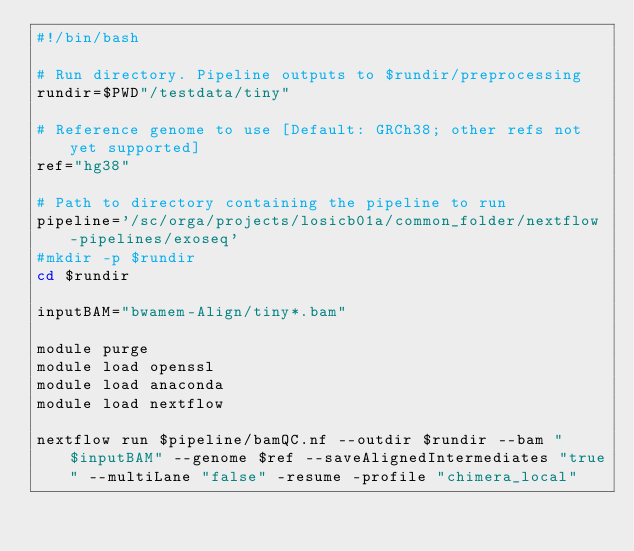<code> <loc_0><loc_0><loc_500><loc_500><_Bash_>#!/bin/bash

# Run directory. Pipeline outputs to $rundir/preprocessing
rundir=$PWD"/testdata/tiny"

# Reference genome to use [Default: GRCh38; other refs not yet supported]
ref="hg38"

# Path to directory containing the pipeline to run
pipeline='/sc/orga/projects/losicb01a/common_folder/nextflow-pipelines/exoseq'
#mkdir -p $rundir
cd $rundir

inputBAM="bwamem-Align/tiny*.bam"

module purge
module load openssl
module load anaconda
module load nextflow

nextflow run $pipeline/bamQC.nf --outdir $rundir --bam "$inputBAM" --genome $ref --saveAlignedIntermediates "true" --multiLane "false" -resume -profile "chimera_local"
</code> 